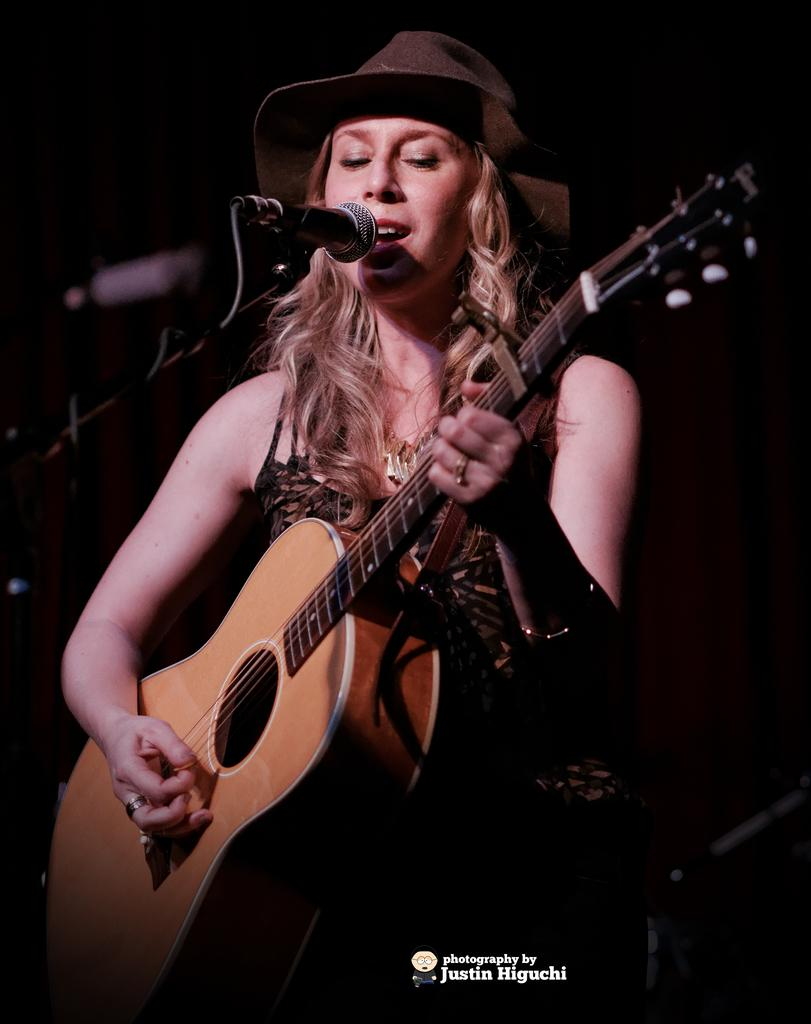What is the main subject of the image? There is a person in the image. What is the person doing in the image? The person is in front of a mic and holding a guitar. How many books can be seen on the person's tongue in the image? There are no books or tongues visible in the image; it features a person holding a guitar in front of a mic. 